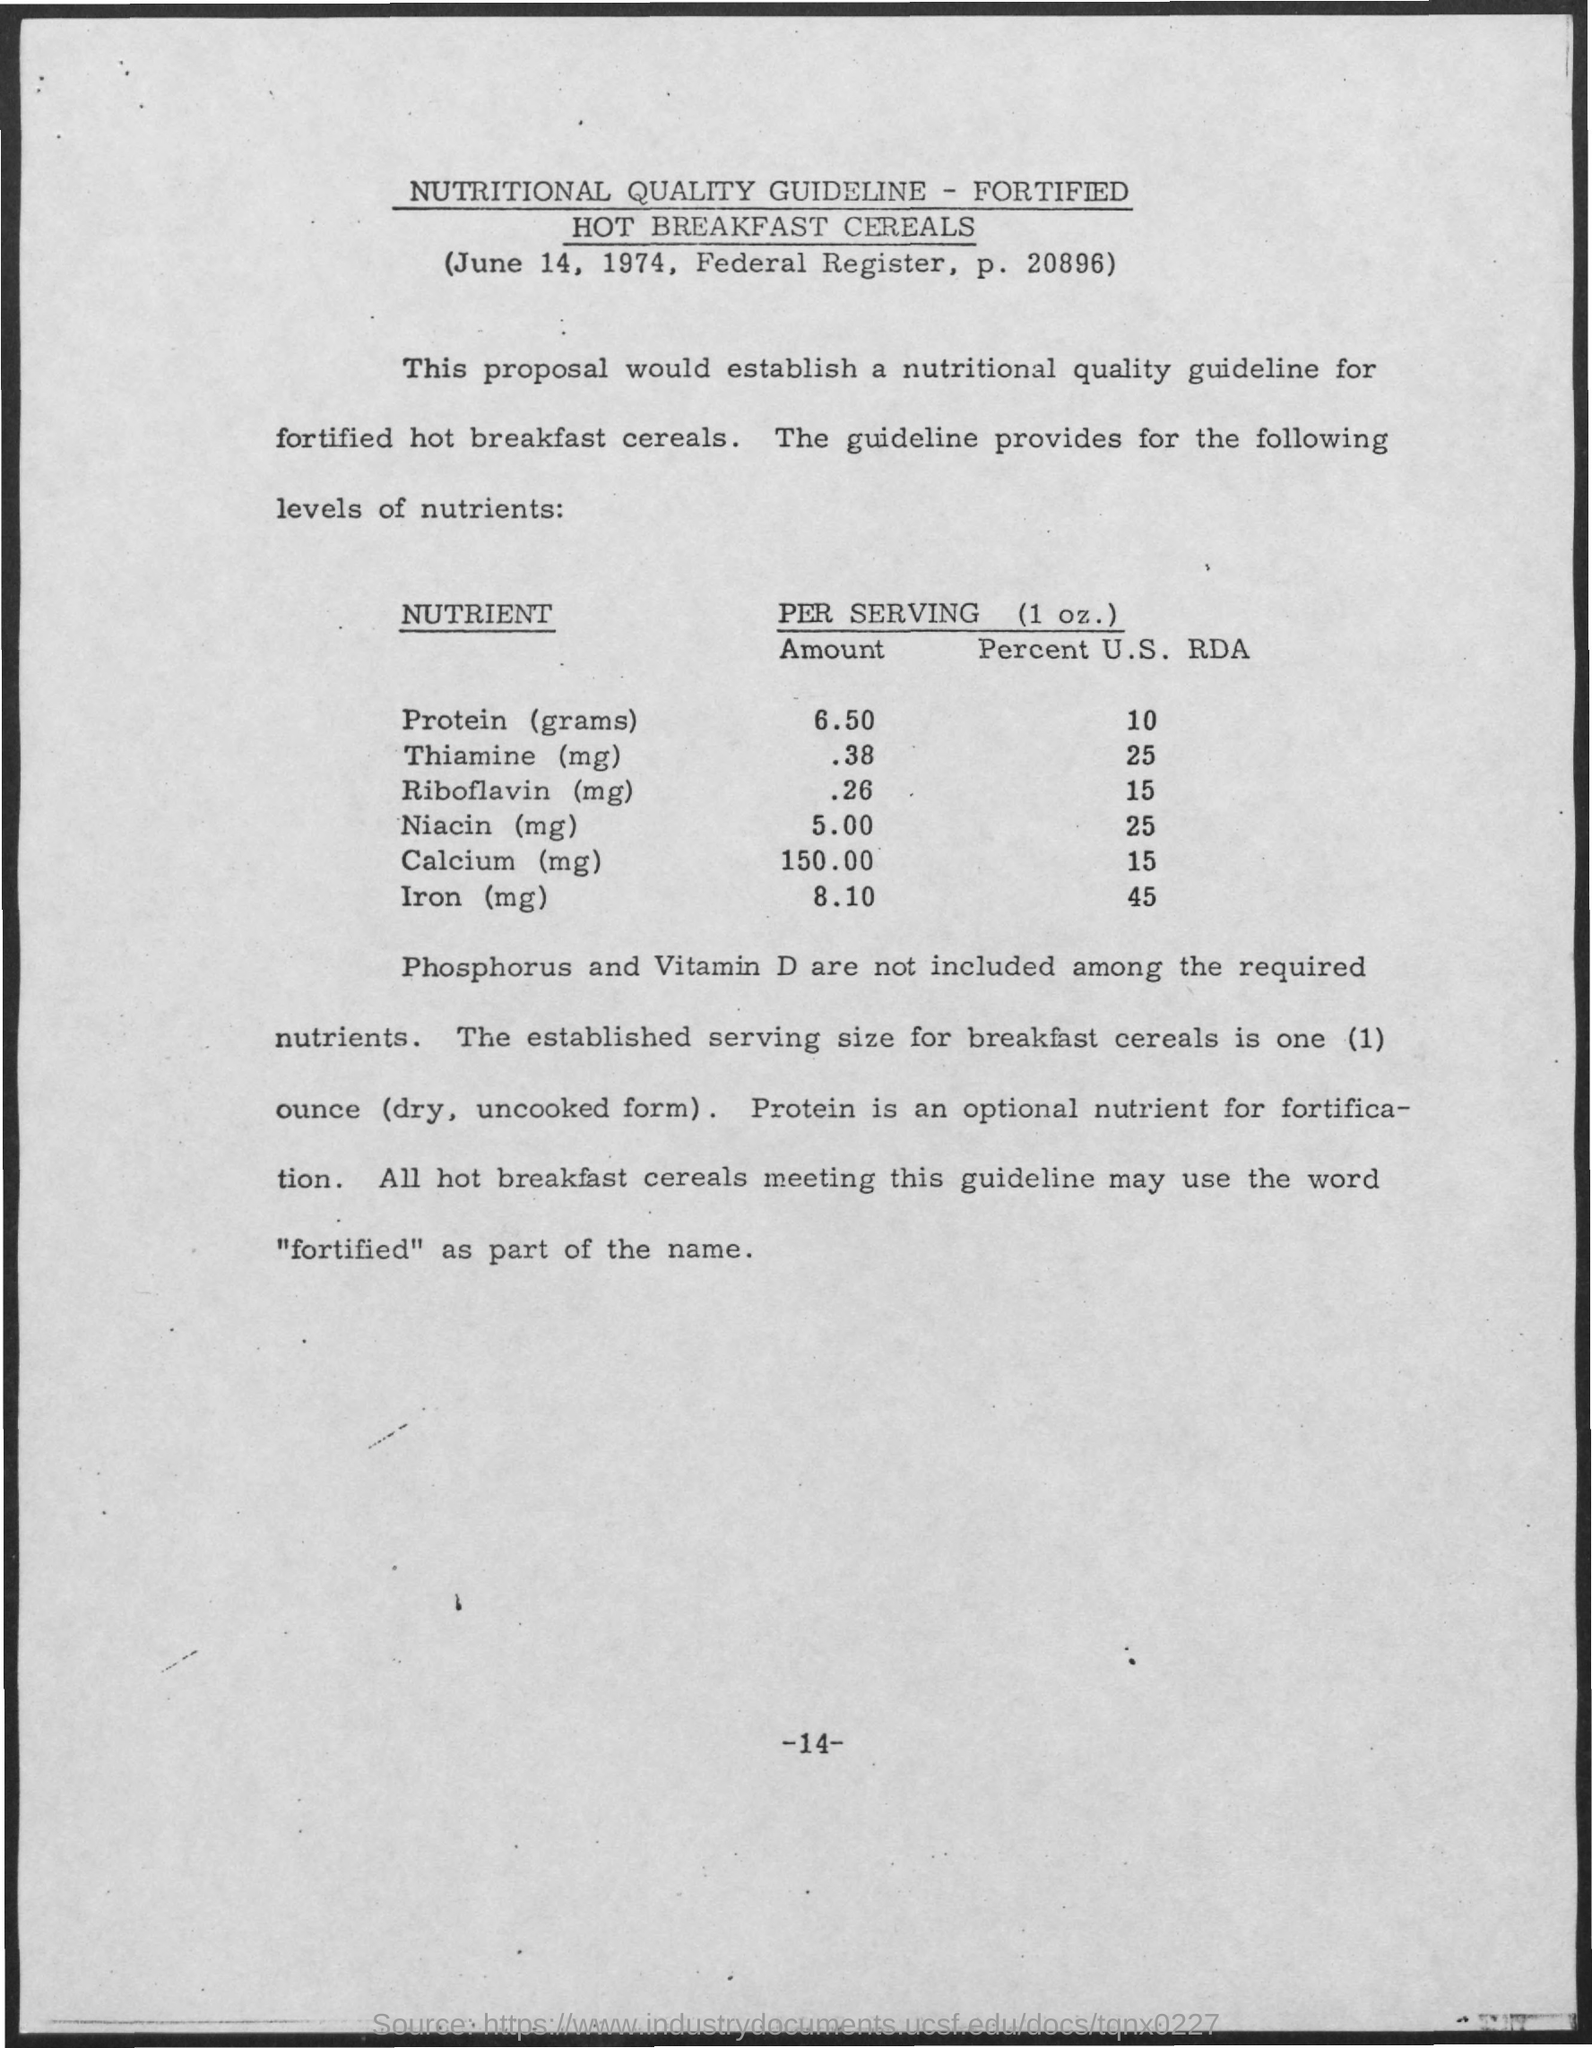Give some essential details in this illustration. The proposal aims to establish a nutritional quality guideline for the fortification of hot breakfast cereals. The date is June 14, 1974. 